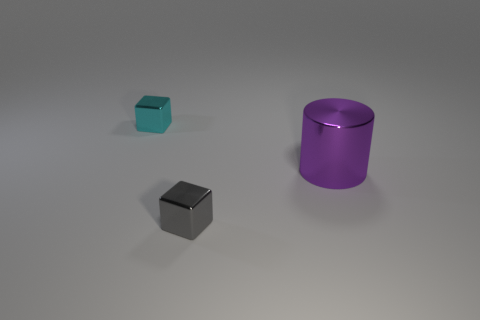Add 1 large purple metallic cubes. How many objects exist? 4 Subtract all cylinders. How many objects are left? 2 Add 3 cylinders. How many cylinders are left? 4 Add 2 large cyan things. How many large cyan things exist? 2 Subtract 0 yellow blocks. How many objects are left? 3 Subtract all large metal balls. Subtract all small gray objects. How many objects are left? 2 